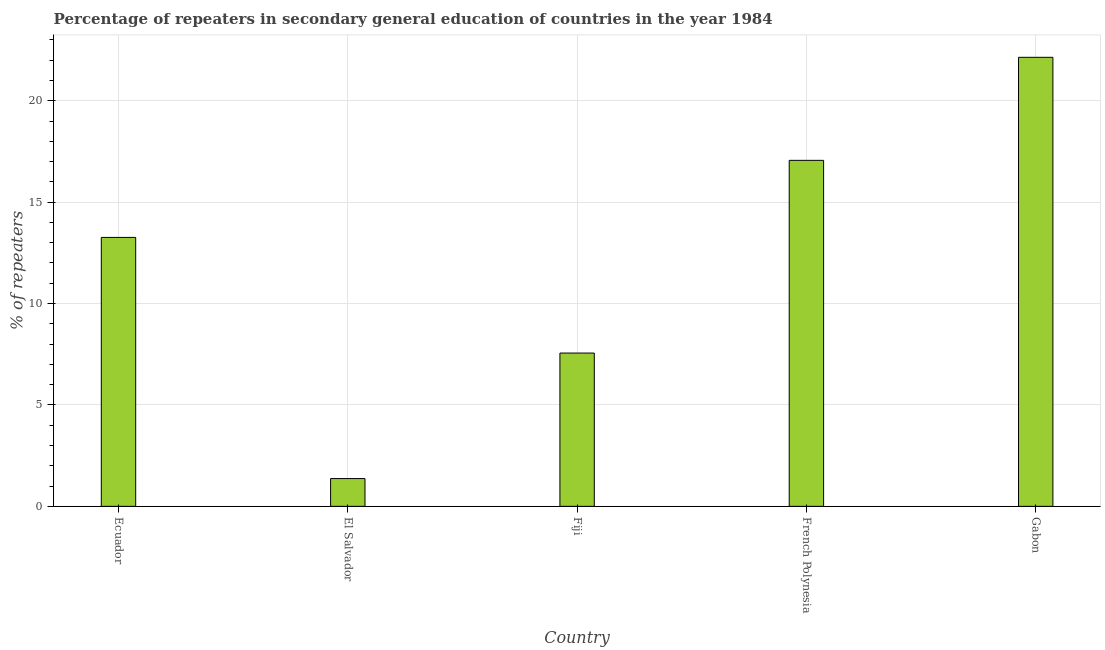Does the graph contain any zero values?
Provide a succinct answer. No. What is the title of the graph?
Your response must be concise. Percentage of repeaters in secondary general education of countries in the year 1984. What is the label or title of the Y-axis?
Provide a short and direct response. % of repeaters. What is the percentage of repeaters in Fiji?
Make the answer very short. 7.56. Across all countries, what is the maximum percentage of repeaters?
Ensure brevity in your answer.  22.14. Across all countries, what is the minimum percentage of repeaters?
Your answer should be compact. 1.37. In which country was the percentage of repeaters maximum?
Your answer should be compact. Gabon. In which country was the percentage of repeaters minimum?
Give a very brief answer. El Salvador. What is the sum of the percentage of repeaters?
Give a very brief answer. 61.39. What is the difference between the percentage of repeaters in Ecuador and El Salvador?
Provide a succinct answer. 11.89. What is the average percentage of repeaters per country?
Offer a terse response. 12.28. What is the median percentage of repeaters?
Your response must be concise. 13.26. In how many countries, is the percentage of repeaters greater than 8 %?
Offer a very short reply. 3. What is the ratio of the percentage of repeaters in French Polynesia to that in Gabon?
Offer a very short reply. 0.77. Is the difference between the percentage of repeaters in Ecuador and Gabon greater than the difference between any two countries?
Offer a very short reply. No. What is the difference between the highest and the second highest percentage of repeaters?
Give a very brief answer. 5.08. Is the sum of the percentage of repeaters in Fiji and Gabon greater than the maximum percentage of repeaters across all countries?
Your response must be concise. Yes. What is the difference between the highest and the lowest percentage of repeaters?
Provide a succinct answer. 20.77. In how many countries, is the percentage of repeaters greater than the average percentage of repeaters taken over all countries?
Ensure brevity in your answer.  3. How many bars are there?
Your answer should be compact. 5. Are all the bars in the graph horizontal?
Make the answer very short. No. What is the difference between two consecutive major ticks on the Y-axis?
Make the answer very short. 5. What is the % of repeaters of Ecuador?
Your response must be concise. 13.26. What is the % of repeaters in El Salvador?
Keep it short and to the point. 1.37. What is the % of repeaters of Fiji?
Your answer should be very brief. 7.56. What is the % of repeaters of French Polynesia?
Provide a short and direct response. 17.06. What is the % of repeaters in Gabon?
Give a very brief answer. 22.14. What is the difference between the % of repeaters in Ecuador and El Salvador?
Give a very brief answer. 11.89. What is the difference between the % of repeaters in Ecuador and Fiji?
Provide a succinct answer. 5.7. What is the difference between the % of repeaters in Ecuador and French Polynesia?
Keep it short and to the point. -3.8. What is the difference between the % of repeaters in Ecuador and Gabon?
Offer a very short reply. -8.88. What is the difference between the % of repeaters in El Salvador and Fiji?
Make the answer very short. -6.19. What is the difference between the % of repeaters in El Salvador and French Polynesia?
Offer a terse response. -15.69. What is the difference between the % of repeaters in El Salvador and Gabon?
Your answer should be very brief. -20.77. What is the difference between the % of repeaters in Fiji and French Polynesia?
Your answer should be very brief. -9.5. What is the difference between the % of repeaters in Fiji and Gabon?
Give a very brief answer. -14.58. What is the difference between the % of repeaters in French Polynesia and Gabon?
Keep it short and to the point. -5.08. What is the ratio of the % of repeaters in Ecuador to that in El Salvador?
Provide a short and direct response. 9.68. What is the ratio of the % of repeaters in Ecuador to that in Fiji?
Your answer should be compact. 1.75. What is the ratio of the % of repeaters in Ecuador to that in French Polynesia?
Make the answer very short. 0.78. What is the ratio of the % of repeaters in Ecuador to that in Gabon?
Your response must be concise. 0.6. What is the ratio of the % of repeaters in El Salvador to that in Fiji?
Offer a very short reply. 0.18. What is the ratio of the % of repeaters in El Salvador to that in Gabon?
Provide a succinct answer. 0.06. What is the ratio of the % of repeaters in Fiji to that in French Polynesia?
Make the answer very short. 0.44. What is the ratio of the % of repeaters in Fiji to that in Gabon?
Ensure brevity in your answer.  0.34. What is the ratio of the % of repeaters in French Polynesia to that in Gabon?
Your answer should be very brief. 0.77. 